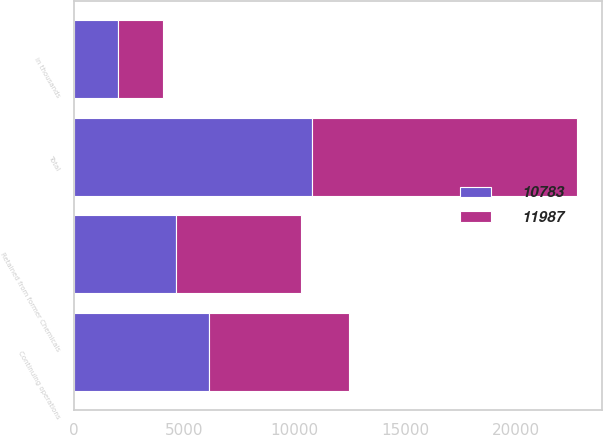Convert chart. <chart><loc_0><loc_0><loc_500><loc_500><stacked_bar_chart><ecel><fcel>in thousands<fcel>Continuing operations<fcel>Retained from former Chemicals<fcel>Total<nl><fcel>11987<fcel>2011<fcel>6335<fcel>5652<fcel>11987<nl><fcel>10783<fcel>2010<fcel>6138<fcel>4645<fcel>10783<nl></chart> 